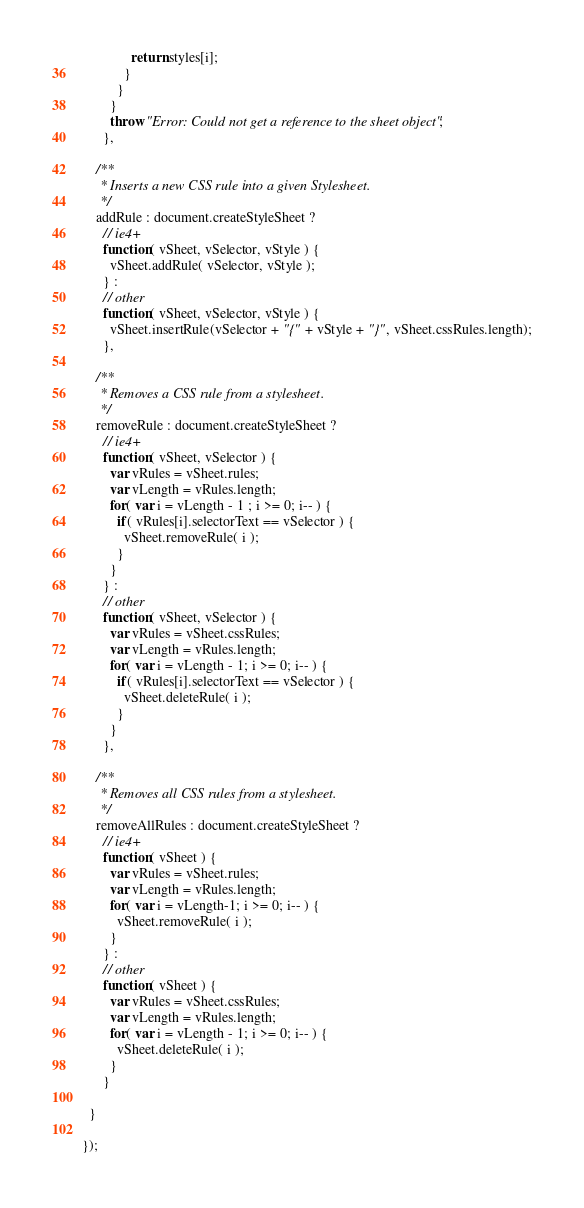Convert code to text. <code><loc_0><loc_0><loc_500><loc_500><_JavaScript_>              return styles[i];
            }
          }
        }
        throw "Error: Could not get a reference to the sheet object";
      },

    /**
     * Inserts a new CSS rule into a given Stylesheet.
     */
    addRule : document.createStyleSheet ?
      // ie4+
      function( vSheet, vSelector, vStyle ) {
        vSheet.addRule( vSelector, vStyle );
      } :
      // other
      function( vSheet, vSelector, vStyle ) {
        vSheet.insertRule(vSelector + "{" + vStyle + "}", vSheet.cssRules.length);
      },

    /**
     * Removes a CSS rule from a stylesheet.
     */
    removeRule : document.createStyleSheet ?
      // ie4+
      function( vSheet, vSelector ) {
        var vRules = vSheet.rules;
        var vLength = vRules.length;
        for( var i = vLength - 1 ; i >= 0; i-- ) {
          if( vRules[i].selectorText == vSelector ) {
            vSheet.removeRule( i );
          }
        }
      } :
      // other
      function( vSheet, vSelector ) {
        var vRules = vSheet.cssRules;
        var vLength = vRules.length;
        for( var i = vLength - 1; i >= 0; i-- ) {
          if( vRules[i].selectorText == vSelector ) {
            vSheet.deleteRule( i );
          }
        }
      },

    /**
     * Removes all CSS rules from a stylesheet.
     */
    removeAllRules : document.createStyleSheet ?
      // ie4+
      function( vSheet ) {
        var vRules = vSheet.rules;
        var vLength = vRules.length;
        for( var i = vLength-1; i >= 0; i-- ) {
          vSheet.removeRule( i );
        }
      } :
      // other
      function( vSheet ) {
        var vRules = vSheet.cssRules;
        var vLength = vRules.length;
        for( var i = vLength - 1; i >= 0; i-- ) {
          vSheet.deleteRule( i );
        }
      }

  }

});
</code> 